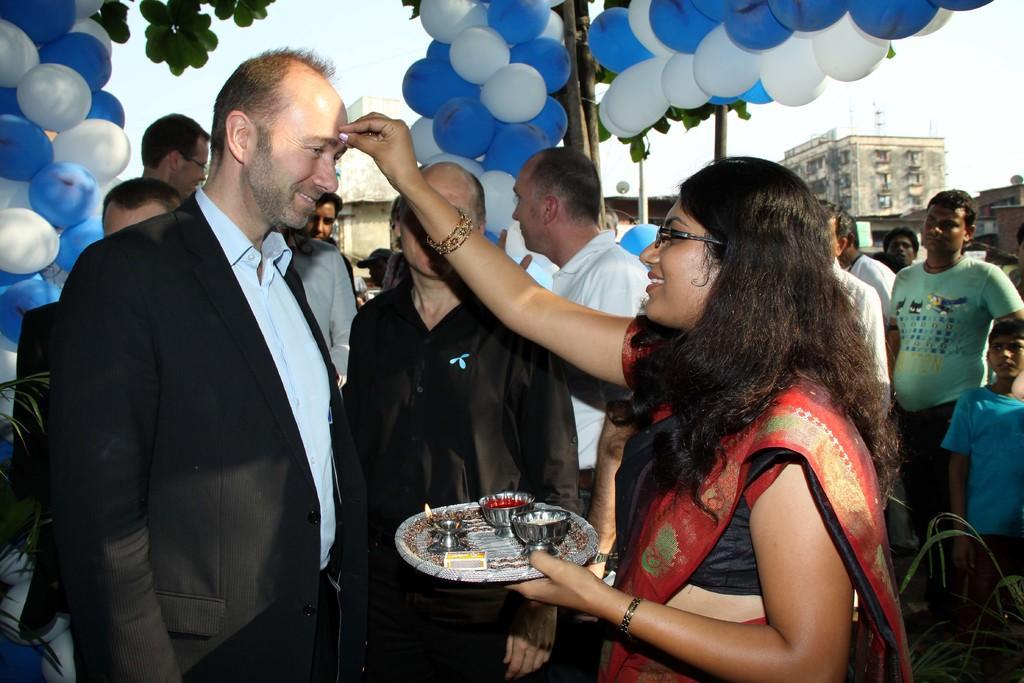Please provide a concise description of this image. In this image there is a person in black suit. He is standing beside a woman. She is holding a plate having two bowls,lamp and match box on it. Behind the few persons are standing on the land. Few balloons are attached to the wooden trunk. Left side there is a plant. Behind there are few balloons. Top of image there are few leaves, behind there is sky. Background there are few buildings. 